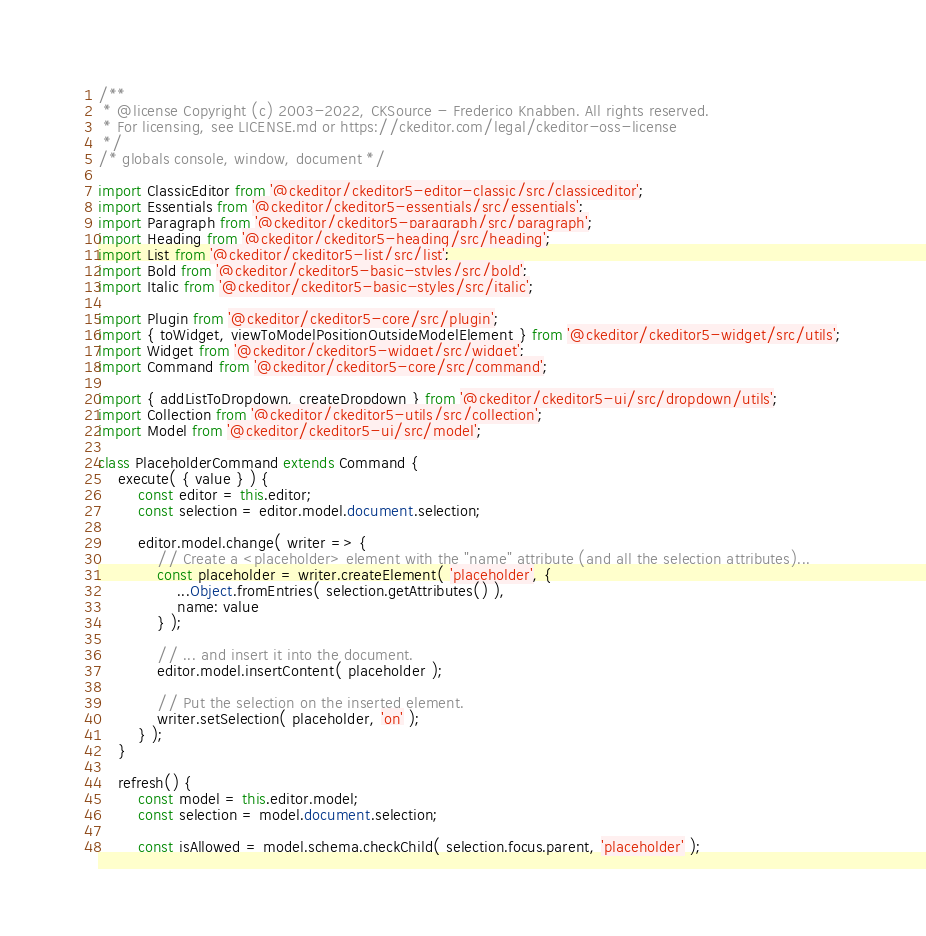Convert code to text. <code><loc_0><loc_0><loc_500><loc_500><_JavaScript_>/**
 * @license Copyright (c) 2003-2022, CKSource - Frederico Knabben. All rights reserved.
 * For licensing, see LICENSE.md or https://ckeditor.com/legal/ckeditor-oss-license
 */
/* globals console, window, document */

import ClassicEditor from '@ckeditor/ckeditor5-editor-classic/src/classiceditor';
import Essentials from '@ckeditor/ckeditor5-essentials/src/essentials';
import Paragraph from '@ckeditor/ckeditor5-paragraph/src/paragraph';
import Heading from '@ckeditor/ckeditor5-heading/src/heading';
import List from '@ckeditor/ckeditor5-list/src/list';
import Bold from '@ckeditor/ckeditor5-basic-styles/src/bold';
import Italic from '@ckeditor/ckeditor5-basic-styles/src/italic';

import Plugin from '@ckeditor/ckeditor5-core/src/plugin';
import { toWidget, viewToModelPositionOutsideModelElement } from '@ckeditor/ckeditor5-widget/src/utils';
import Widget from '@ckeditor/ckeditor5-widget/src/widget';
import Command from '@ckeditor/ckeditor5-core/src/command';

import { addListToDropdown, createDropdown } from '@ckeditor/ckeditor5-ui/src/dropdown/utils';
import Collection from '@ckeditor/ckeditor5-utils/src/collection';
import Model from '@ckeditor/ckeditor5-ui/src/model';

class PlaceholderCommand extends Command {
	execute( { value } ) {
		const editor = this.editor;
		const selection = editor.model.document.selection;

		editor.model.change( writer => {
			// Create a <placeholder> element with the "name" attribute (and all the selection attributes)...
			const placeholder = writer.createElement( 'placeholder', {
				...Object.fromEntries( selection.getAttributes() ),
				name: value
			} );

			// ... and insert it into the document.
			editor.model.insertContent( placeholder );

			// Put the selection on the inserted element.
			writer.setSelection( placeholder, 'on' );
		} );
	}

	refresh() {
		const model = this.editor.model;
		const selection = model.document.selection;

		const isAllowed = model.schema.checkChild( selection.focus.parent, 'placeholder' );
</code> 